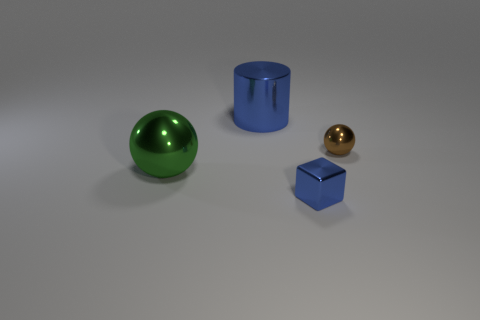Add 1 blue metallic cubes. How many objects exist? 5 Subtract all red balls. Subtract all blue cylinders. How many balls are left? 2 Subtract all blocks. How many objects are left? 3 Subtract all green spheres. Subtract all green things. How many objects are left? 2 Add 4 metal cylinders. How many metal cylinders are left? 5 Add 3 large blue metallic objects. How many large blue metallic objects exist? 4 Subtract 0 green blocks. How many objects are left? 4 